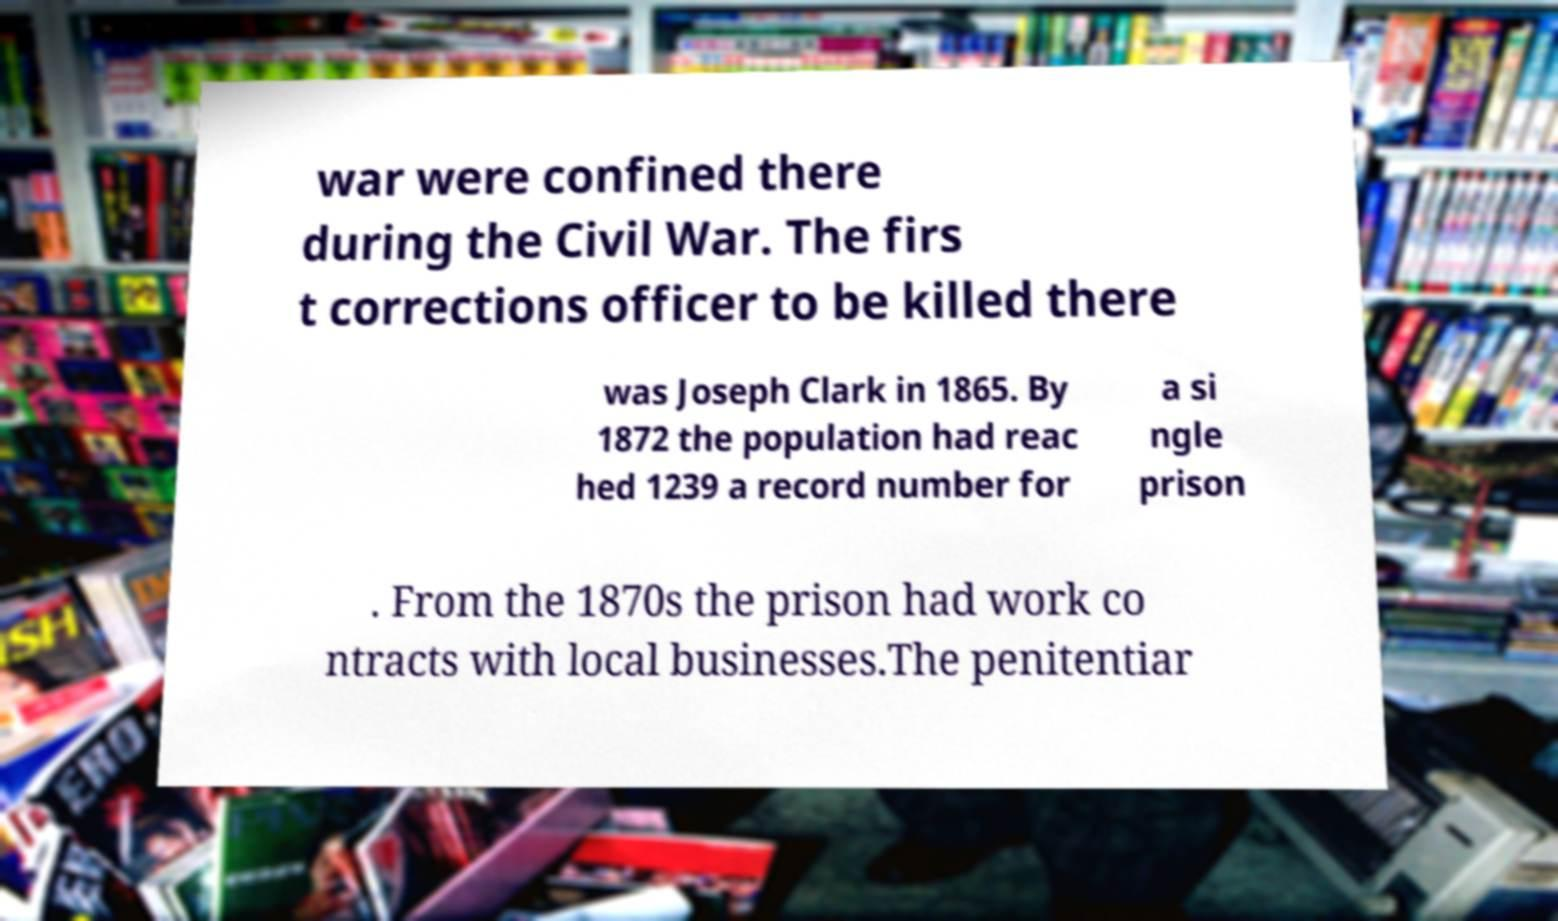Could you assist in decoding the text presented in this image and type it out clearly? war were confined there during the Civil War. The firs t corrections officer to be killed there was Joseph Clark in 1865. By 1872 the population had reac hed 1239 a record number for a si ngle prison . From the 1870s the prison had work co ntracts with local businesses.The penitentiar 